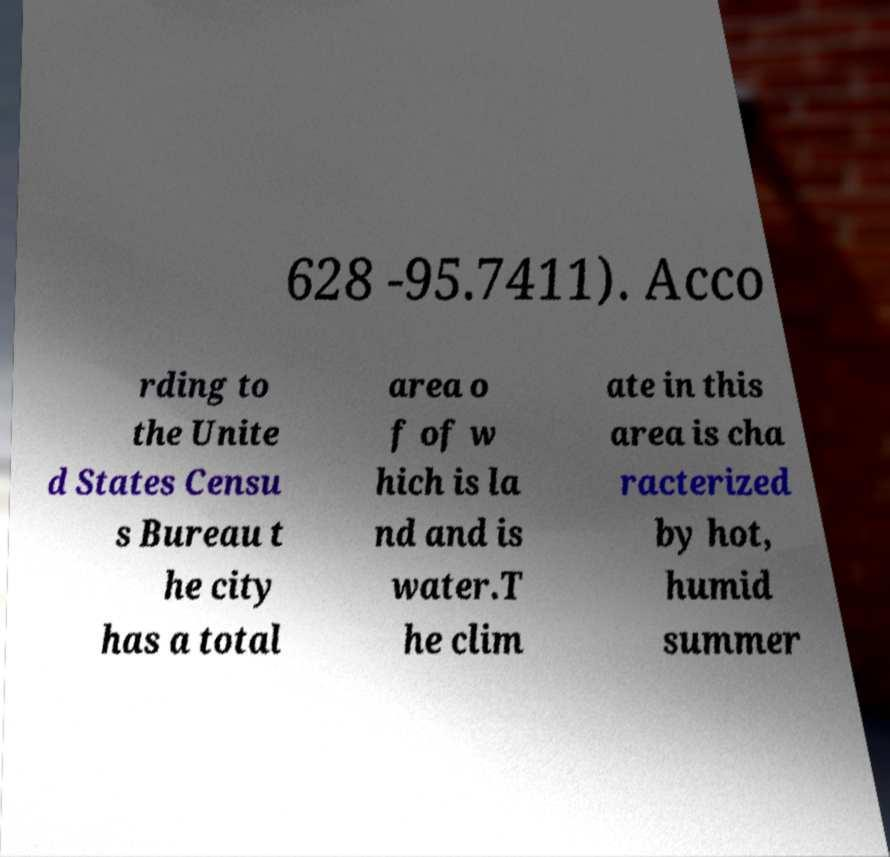Could you extract and type out the text from this image? 628 -95.7411). Acco rding to the Unite d States Censu s Bureau t he city has a total area o f of w hich is la nd and is water.T he clim ate in this area is cha racterized by hot, humid summer 